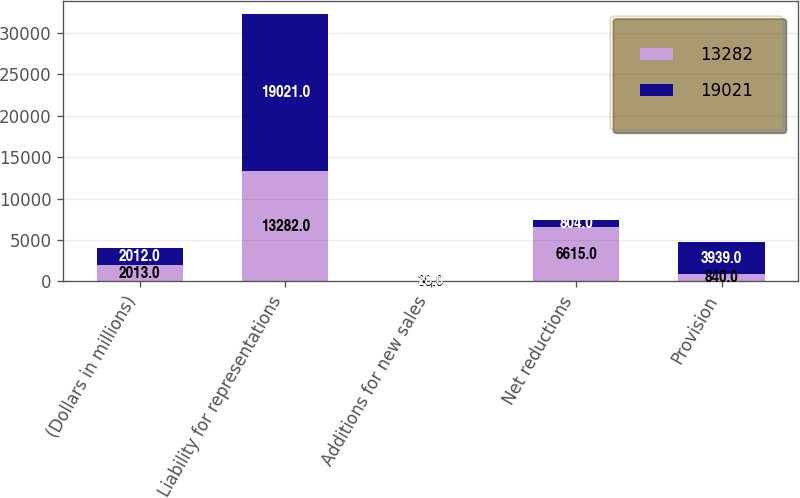<chart> <loc_0><loc_0><loc_500><loc_500><stacked_bar_chart><ecel><fcel>(Dollars in millions)<fcel>Liability for representations<fcel>Additions for new sales<fcel>Net reductions<fcel>Provision<nl><fcel>13282<fcel>2013<fcel>13282<fcel>36<fcel>6615<fcel>840<nl><fcel>19021<fcel>2012<fcel>19021<fcel>28<fcel>804<fcel>3939<nl></chart> 